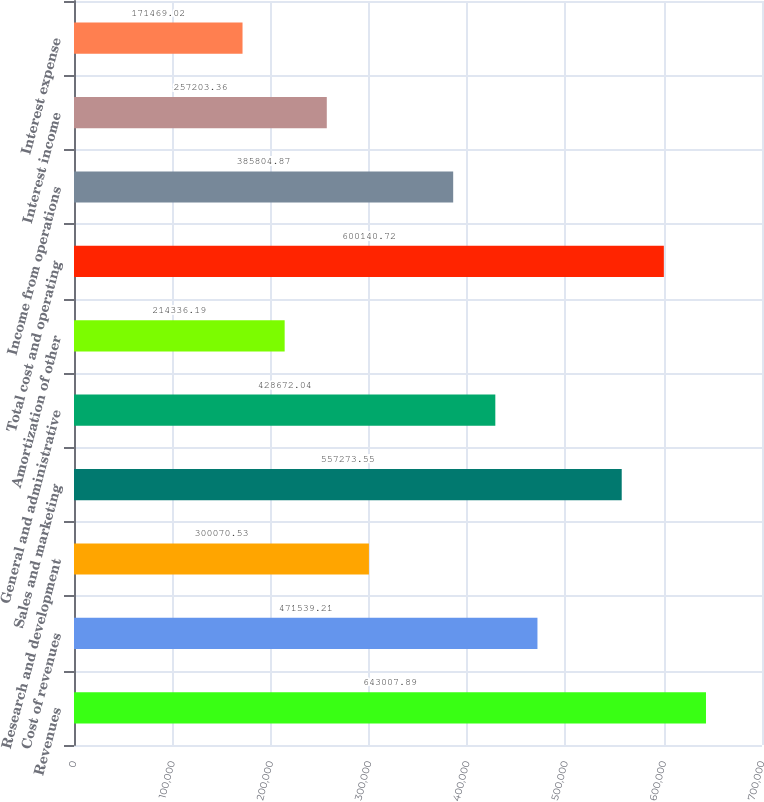Convert chart. <chart><loc_0><loc_0><loc_500><loc_500><bar_chart><fcel>Revenues<fcel>Cost of revenues<fcel>Research and development<fcel>Sales and marketing<fcel>General and administrative<fcel>Amortization of other<fcel>Total cost and operating<fcel>Income from operations<fcel>Interest income<fcel>Interest expense<nl><fcel>643008<fcel>471539<fcel>300071<fcel>557274<fcel>428672<fcel>214336<fcel>600141<fcel>385805<fcel>257203<fcel>171469<nl></chart> 